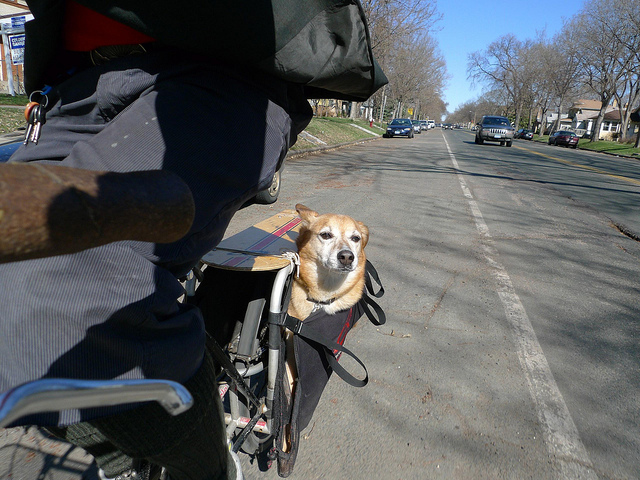How is the dog probably traveling? The dog is probably traveling by bike. It is comfortably seated in a basket attached to the back of the bicycle, secured with straps, and enjoying the ride. 